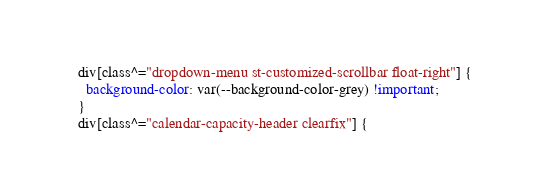Convert code to text. <code><loc_0><loc_0><loc_500><loc_500><_CSS_>div[class^="dropdown-menu st-customized-scrollbar float-right"] {
  background-color: var(--background-color-grey) !important;
}
div[class^="calendar-capacity-header clearfix"] {</code> 